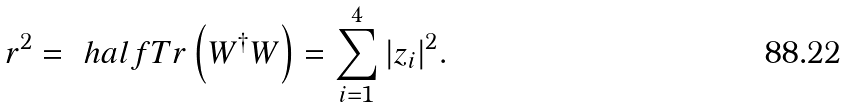Convert formula to latex. <formula><loc_0><loc_0><loc_500><loc_500>r ^ { 2 } = \ h a l f T r \left ( W ^ { \dagger } W \right ) = \sum _ { i = 1 } ^ { 4 } | z _ { i } | ^ { 2 } .</formula> 